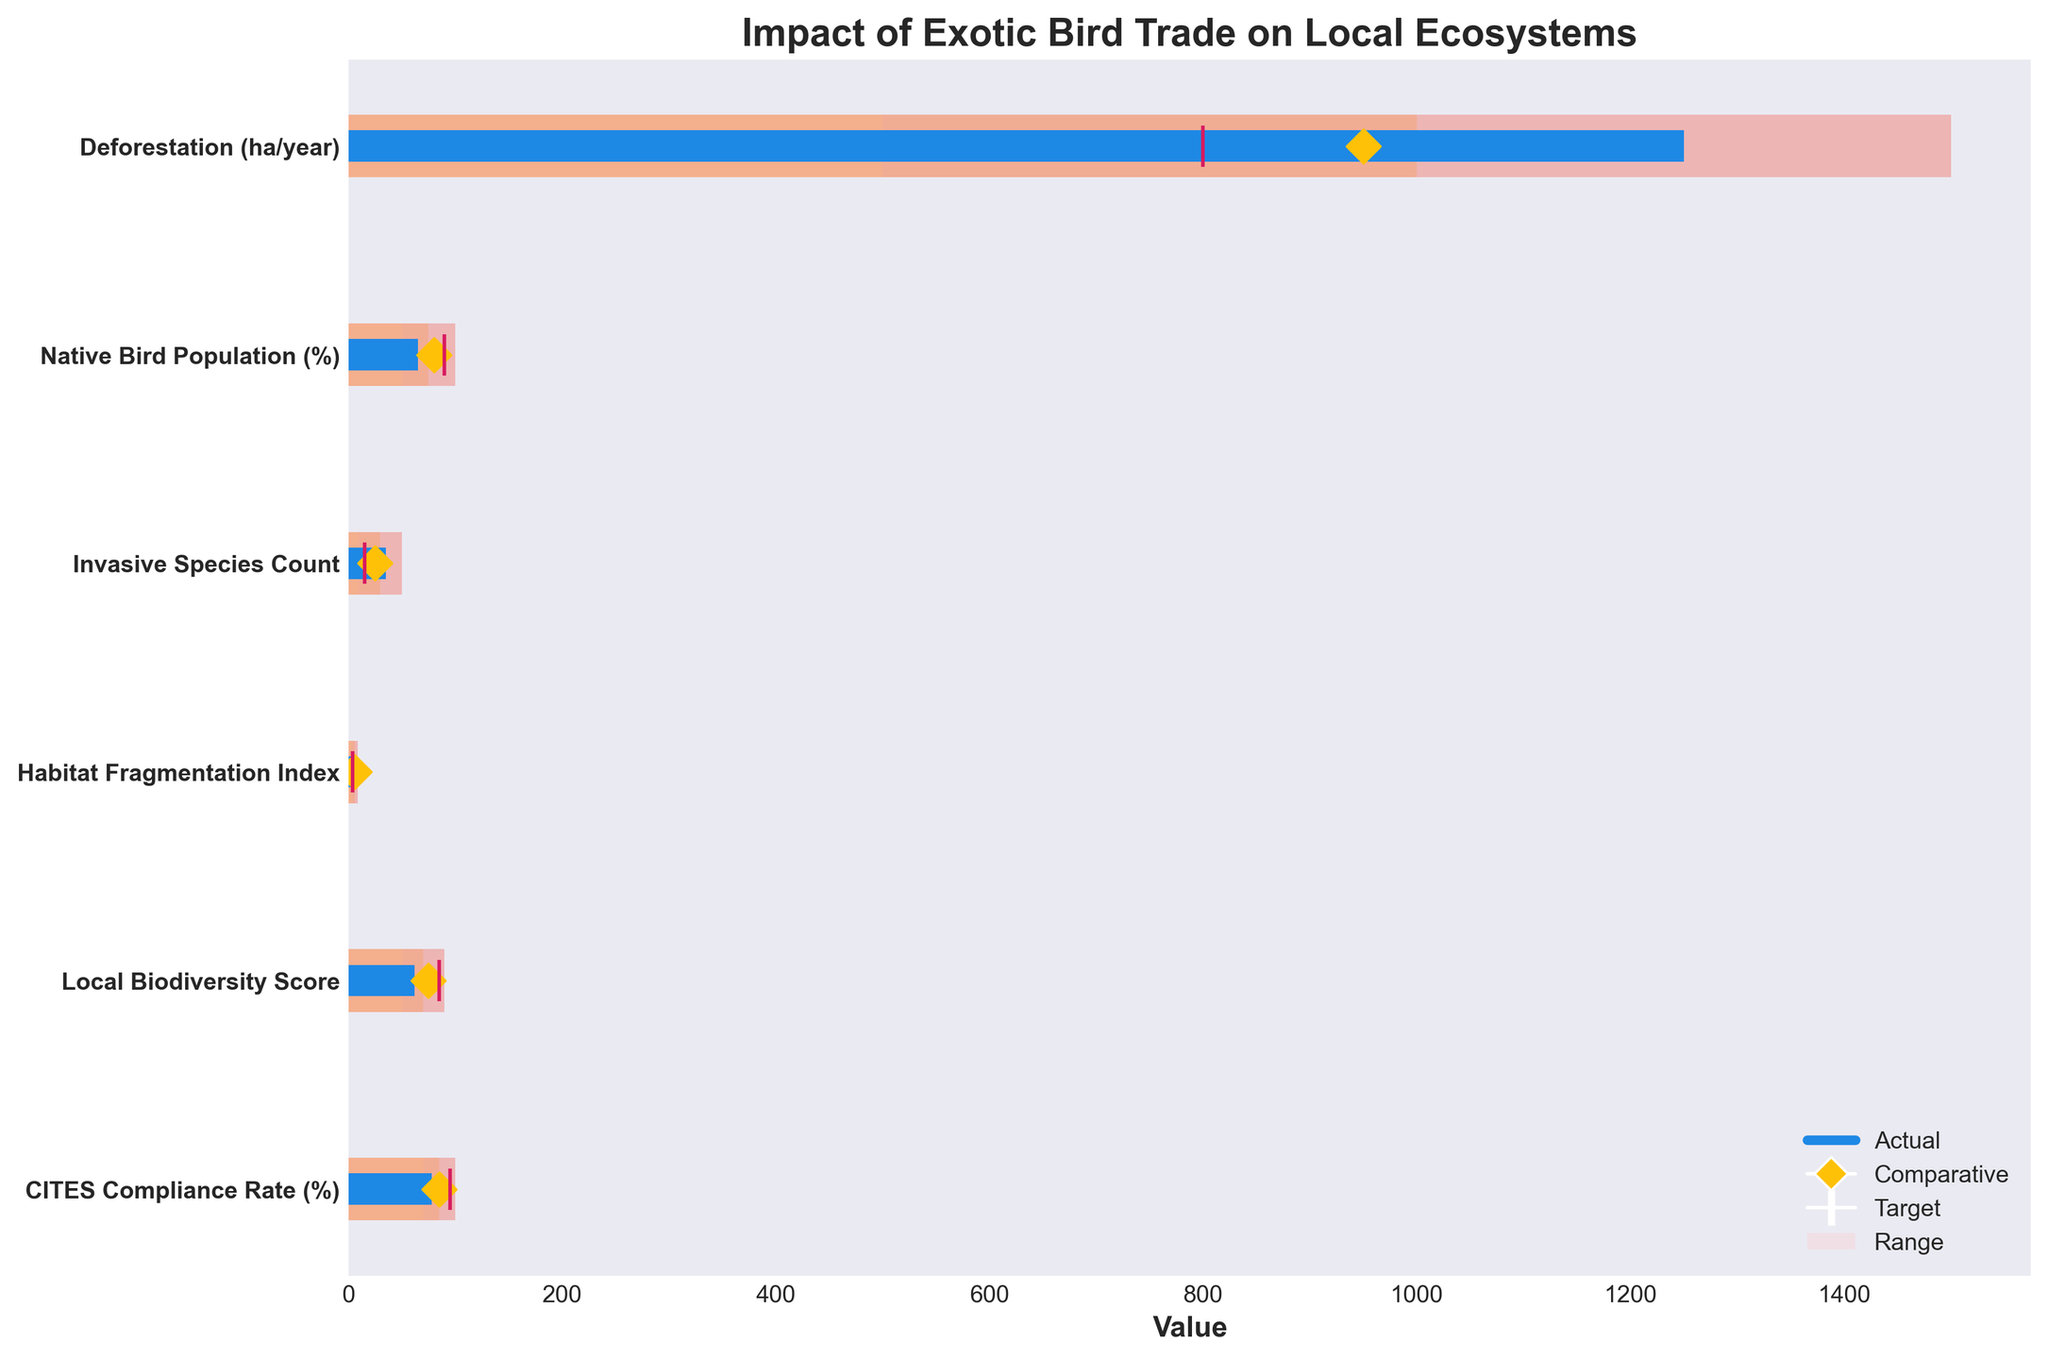What's the title of the figure? The title is usually found at the top of a figure, and it introduces the main topic of the chart. In this case, it says "Impact of Exotic Bird Trade on Local Ecosystems".
Answer: Impact of Exotic Bird Trade on Local Ecosystems What is the actual deforestation rate in ha/year? The actual values are represented by horizontal blue bars. For deforestation, the blue bar reaches 1250.
Answer: 1250 Which category has the highest comparative value? The comparative values are represented by yellow diamond markers. CITES Compliance Rate has the highest yellow diamond marker at 85.
Answer: CITES Compliance Rate How does the actual native bird population compare to its target? The actual value for Native Bird Population is 65%, represented by a blue bar, and its target, represented by a vertical pink line, is 90%. Comparing these two, the actual value is lower than the target.
Answer: Lower What is the range of values for Local Biodiversity Score? The predefined ranges for each category are the shaded areas in light colors. For Local Biodiversity Score, the ranges from lightest to darkest are: 50-70, 70-85, and 85-90. The full range is from 50 to 90.
Answer: 50 to 90 Which category shows the smallest gap between the actual and comparative values? By visually comparing the blue bar (actual) and the yellow diamond (comparative) for each category, CITES Compliance Rate shows the smallest gap, as it has an actual value of 78 and comparative value of 85, yielding a difference of 7.
Answer: CITES Compliance Rate Compare the actual and target values for Habitat Fragmentation Index. Which is greater? The actual value of Habitat Fragmentation Index is 6.8 (blue bar), and the target value is 4.0 (vertical pink line). The actual value is greater.
Answer: Actual is greater What is the range for the lowest tier in the Invasive Species Count category? The lowest tier of the shaded areas for each category is depicted in the lightest color. For Invasive Species Count, the lowest tier falls within the range of 10 to 30.
Answer: 10 to 30 How does the actual local biodiversity score compare to its range? The actual local biodiversity score is 62, represented by a blue bar. The first range tier (lightest color) is 50-70. Since 62 falls within this range, it is within the first tier range.
Answer: Within range Is the actual rate of CITES Compliance above the target? The actual rate (blue bar) is 78%, and the target (vertical pink line) is 95%. The actual rate is indeed below the target.
Answer: Below 